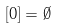Convert formula to latex. <formula><loc_0><loc_0><loc_500><loc_500>[ 0 ] = \emptyset</formula> 